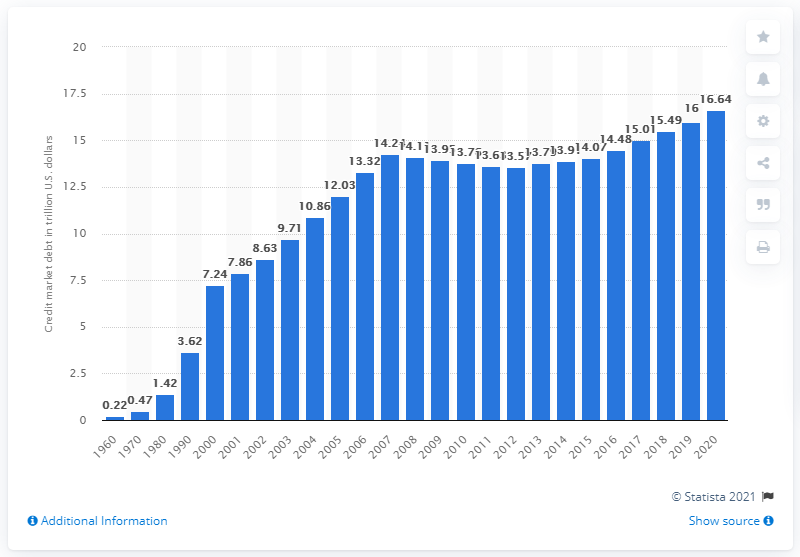Give some essential details in this illustration. At the end of 2020, the credit market debt of households and nonprofit organizations was 16.64. 